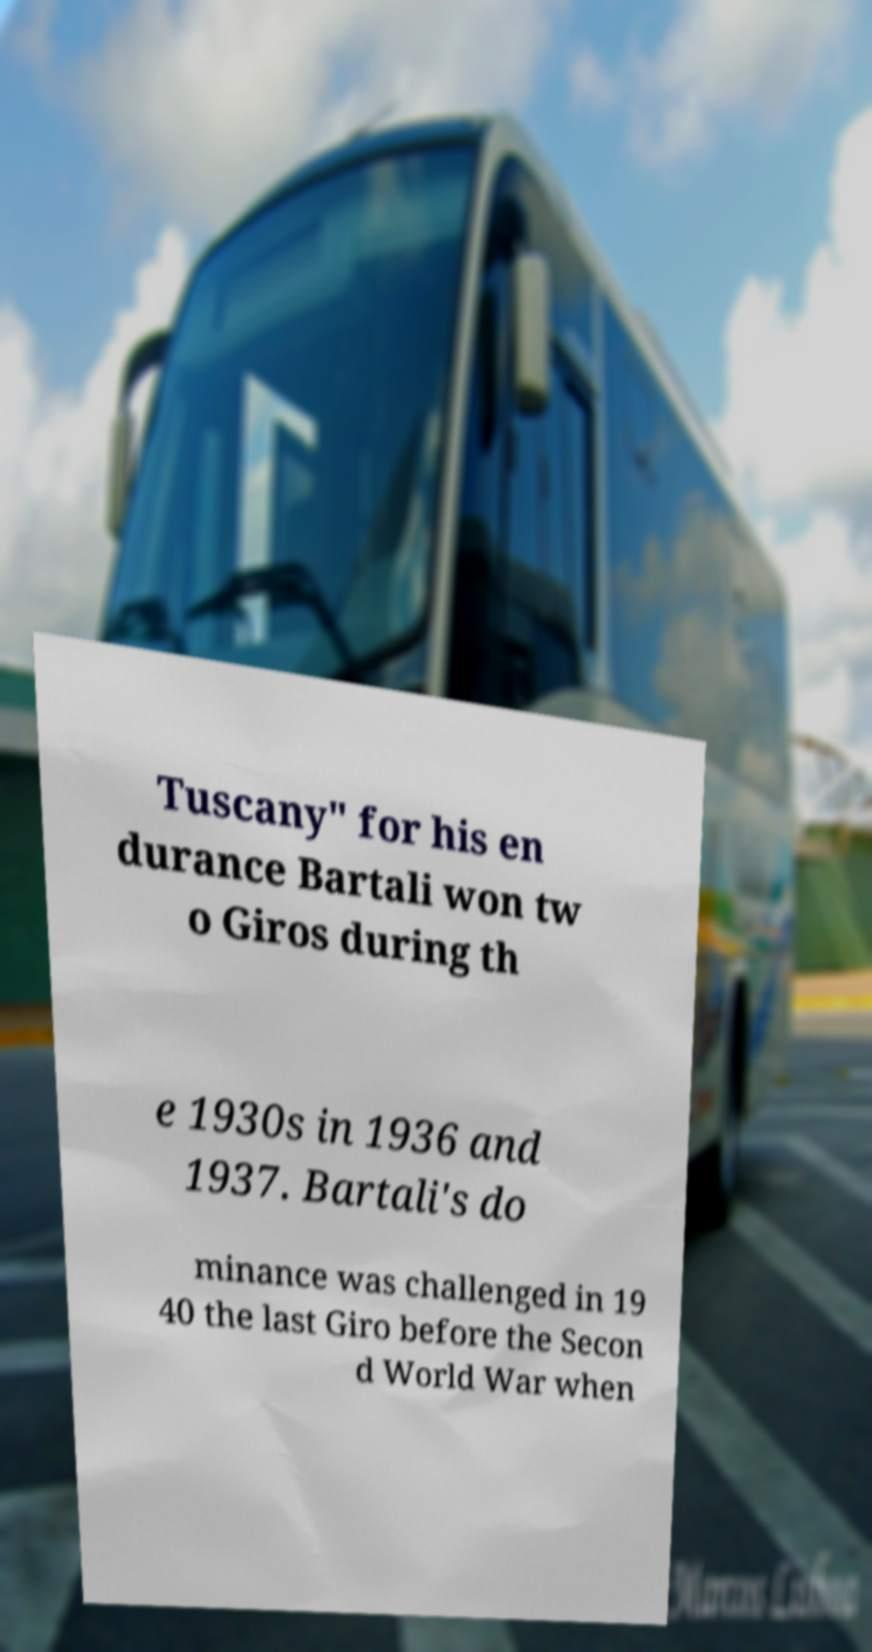I need the written content from this picture converted into text. Can you do that? Tuscany" for his en durance Bartali won tw o Giros during th e 1930s in 1936 and 1937. Bartali's do minance was challenged in 19 40 the last Giro before the Secon d World War when 